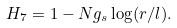<formula> <loc_0><loc_0><loc_500><loc_500>H _ { 7 } = 1 - N g _ { s } \log ( r / l ) .</formula> 